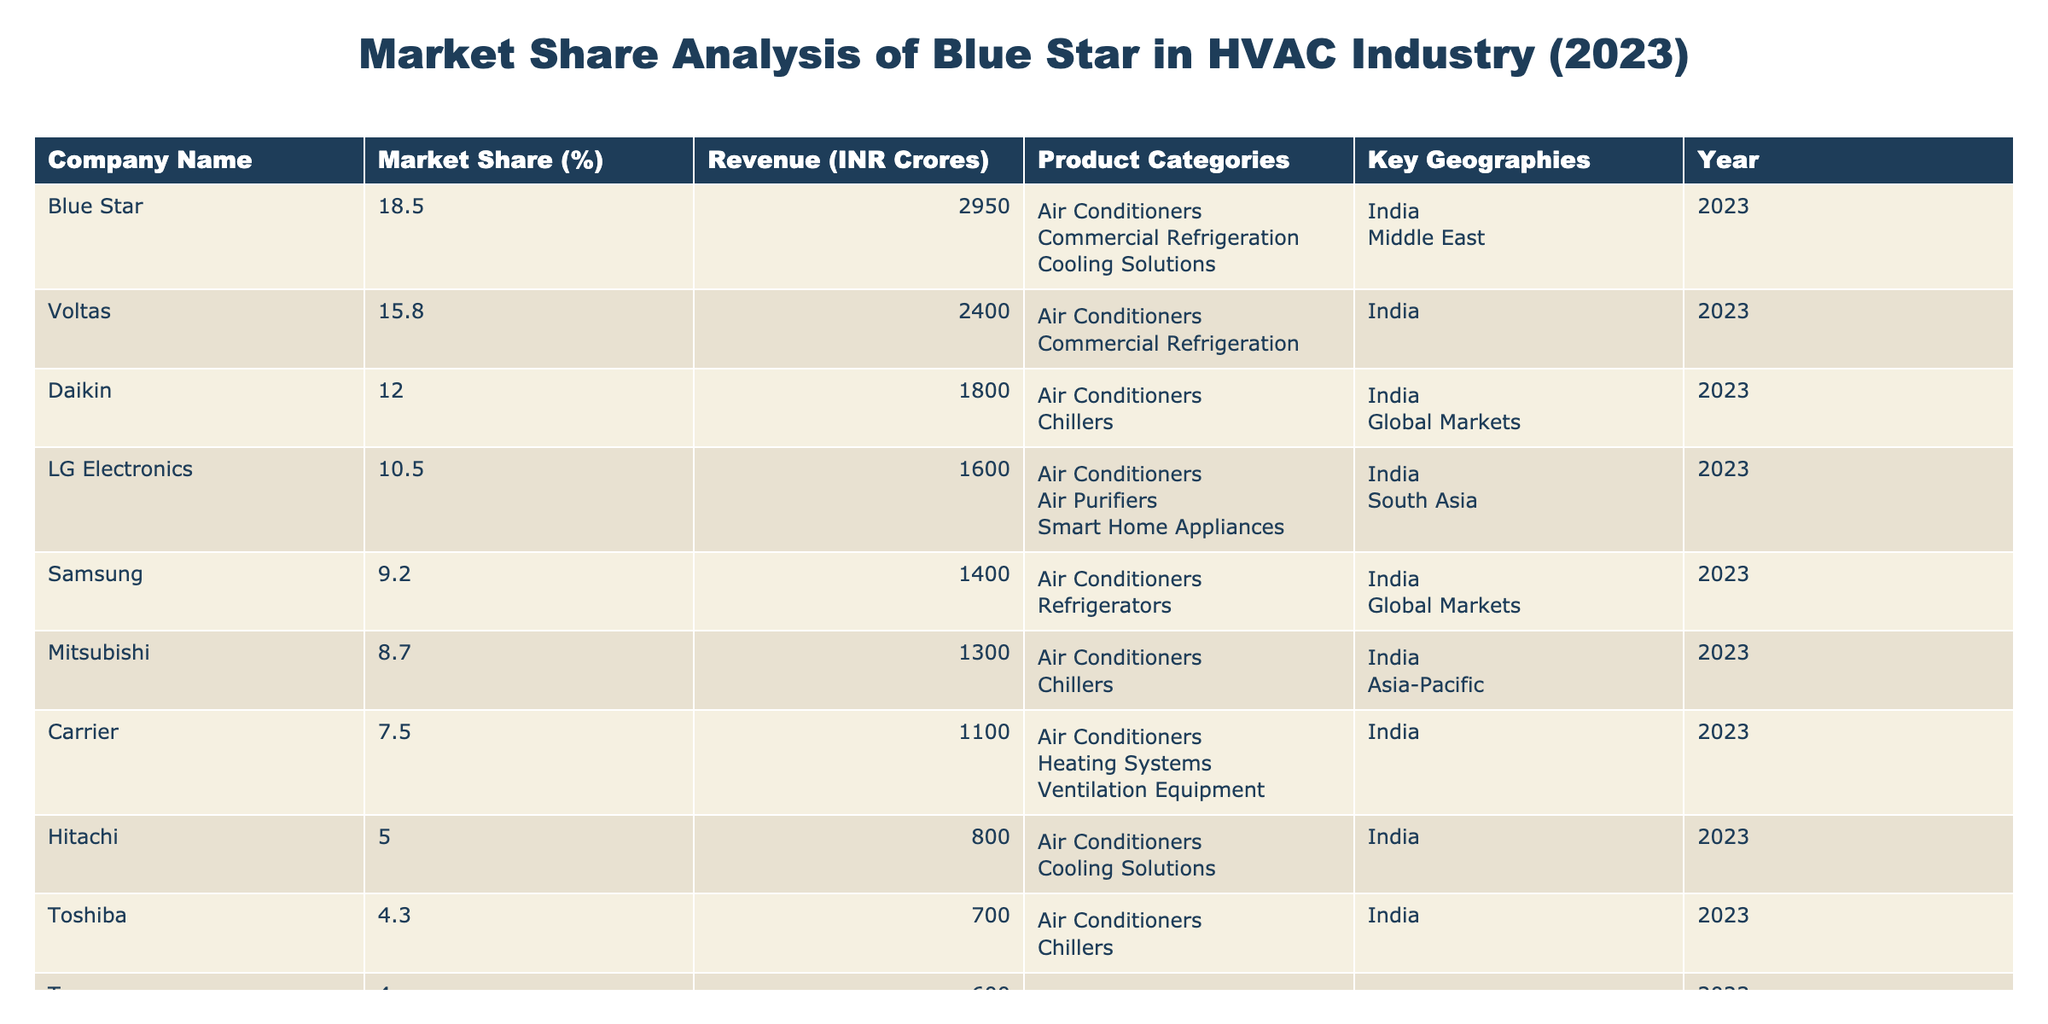What is Blue Star's market share percentage in the HVAC industry? The table shows that Blue Star has a market share of 18.5% in the HVAC industry for the year 2023.
Answer: 18.5% What is the revenue of Carrier in INR Crores? According to the table, Carrier's revenue is listed as 1100 INR Crores.
Answer: 1100 Which company has the highest market share in the table? The table indicates that Blue Star holds the highest market share at 18.5%, compared to other companies listed.
Answer: Blue Star What is the difference in revenue between Blue Star and Daikin? Blue Star's revenue is 2950 INR Crores and Daikin's is 1800 INR Crores. The difference is calculated as 2950 - 1800 = 1150.
Answer: 1150 How many product categories does LG Electronics operate in? The table states that LG Electronics operates in three product categories: Air Conditioners, Air Purifiers, and Smart Home Appliances.
Answer: 3 Is it true that Samsung has a market share greater than Hitachi? The table shows Samsung has a market share of 9.2% and Hitachi has 5.0%. Therefore, this statement is true as 9.2% is greater than 5.0%.
Answer: True What are the key geographies for Mitsubishi? According to the table, Mitsubishi's key geographies are India and Asia-Pacific.
Answer: India; Asia-Pacific If you sum the market shares of Blue Star and Voltas, what value do you get? Blue Star's market share is 18.5% and Voltas’ is 15.8%. The sum is 18.5 + 15.8 = 34.3%.
Answer: 34.3% Which company has the lowest revenue among the listed companies? The table presents that Trane has the lowest revenue at 600 INR Crores compared to others.
Answer: Trane How many companies have a market share greater than 10%? Blue Star, Voltas, Daikin, and LG Electronics have market shares greater than 10%. There are four companies.
Answer: 4 